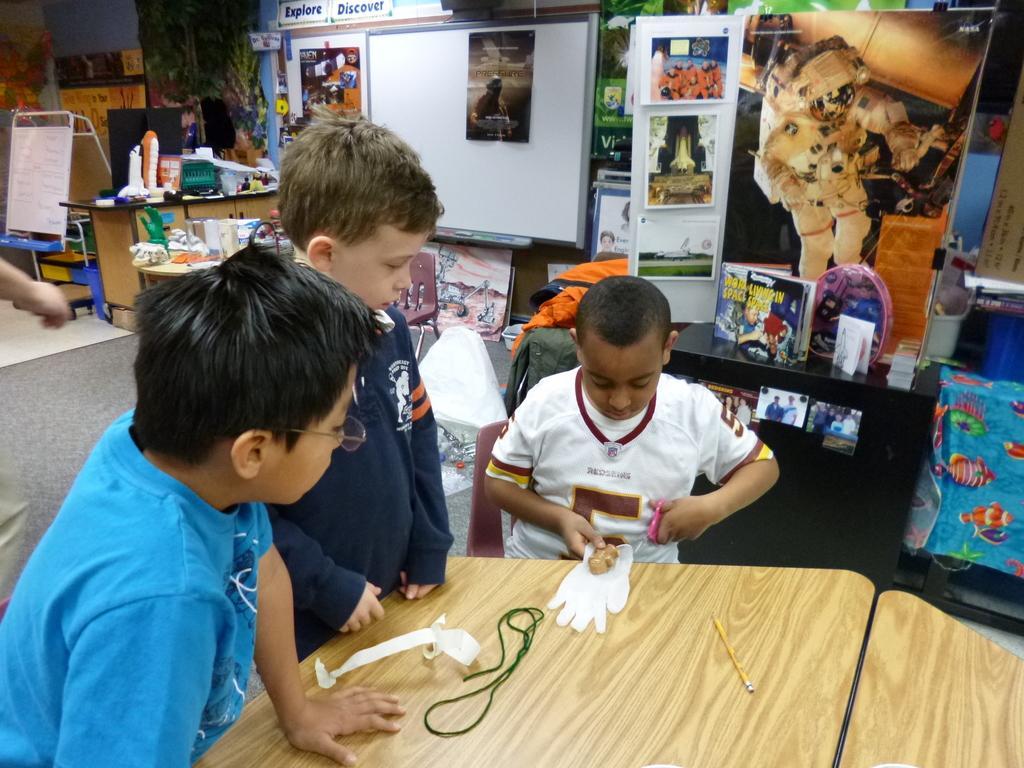Describe this image in one or two sentences. On the left side, there are two children in different color t-shirts. In front of them, there is a wooden table, on which there is a pencil, a green color thread and other objects. Behind them, there is another child in a white color t-shirt, holding a scissor with a hand, sitting. In the background, there are posters, a white board, a hand of a person and other objects. 